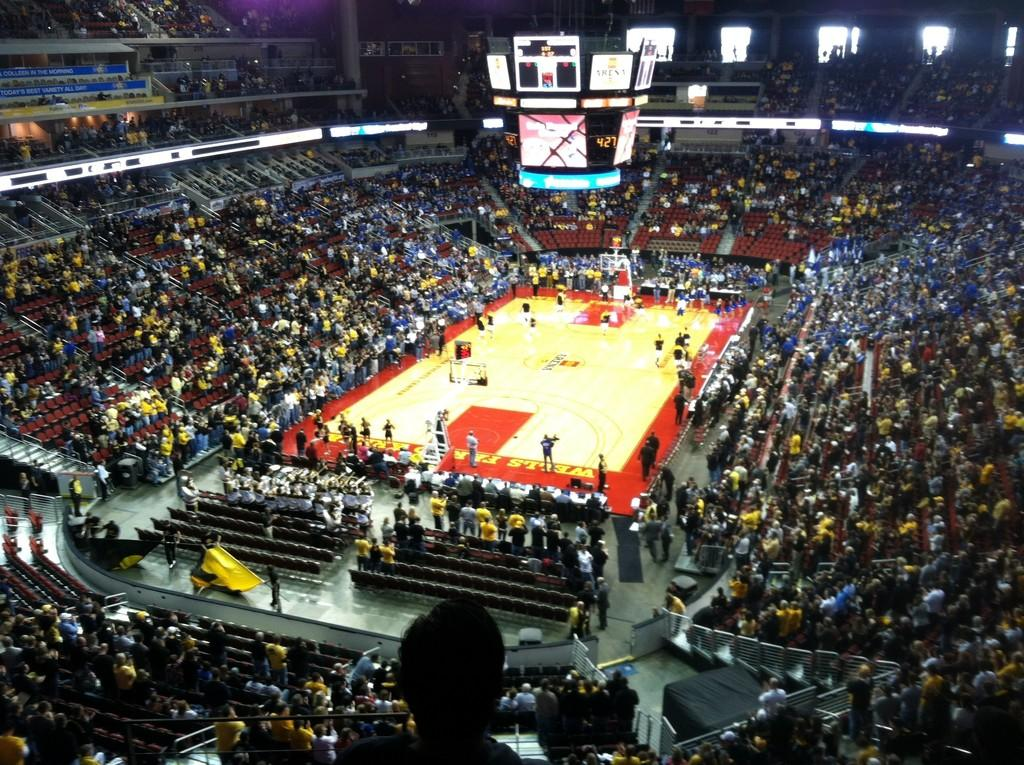<image>
Create a compact narrative representing the image presented. a basketball court with a scoreboard that had 427 on it 